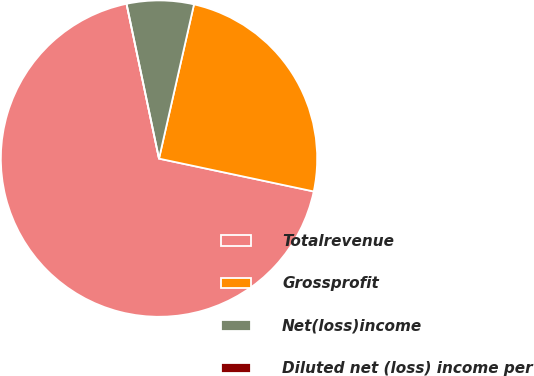<chart> <loc_0><loc_0><loc_500><loc_500><pie_chart><fcel>Totalrevenue<fcel>Grossprofit<fcel>Net(loss)income<fcel>Diluted net (loss) income per<nl><fcel>68.38%<fcel>24.78%<fcel>6.84%<fcel>0.0%<nl></chart> 